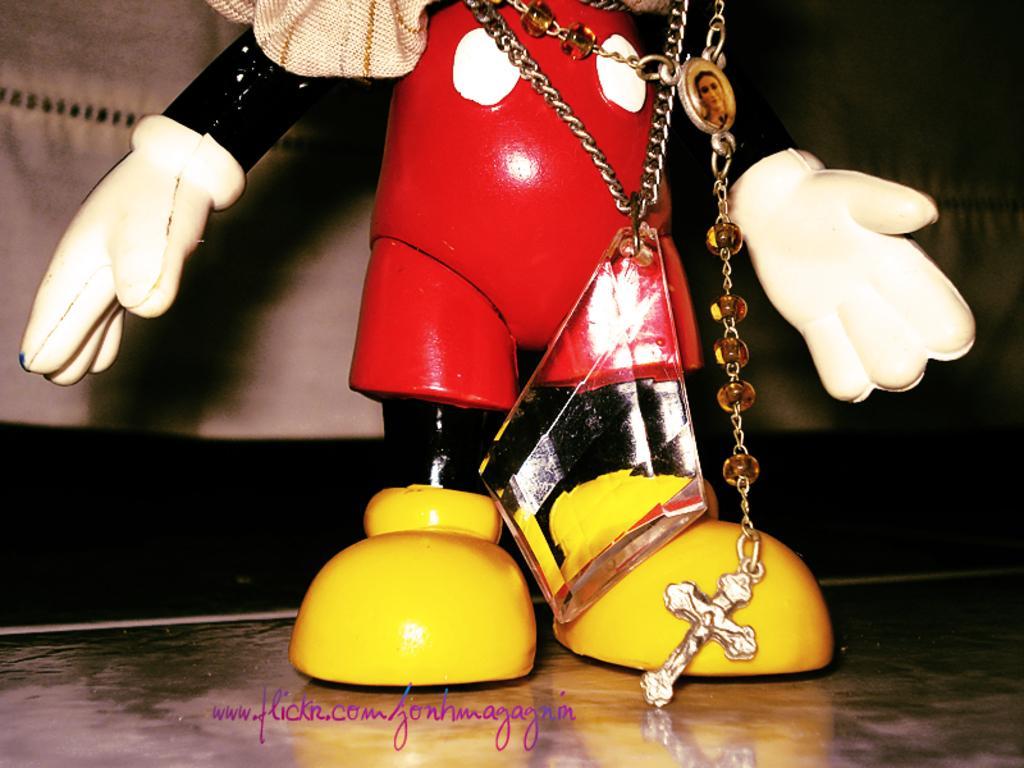In one or two sentences, can you explain what this image depicts? In the picture I can see a toy and some other things. I can also see a watermark on the image. The background of the image is dark. 